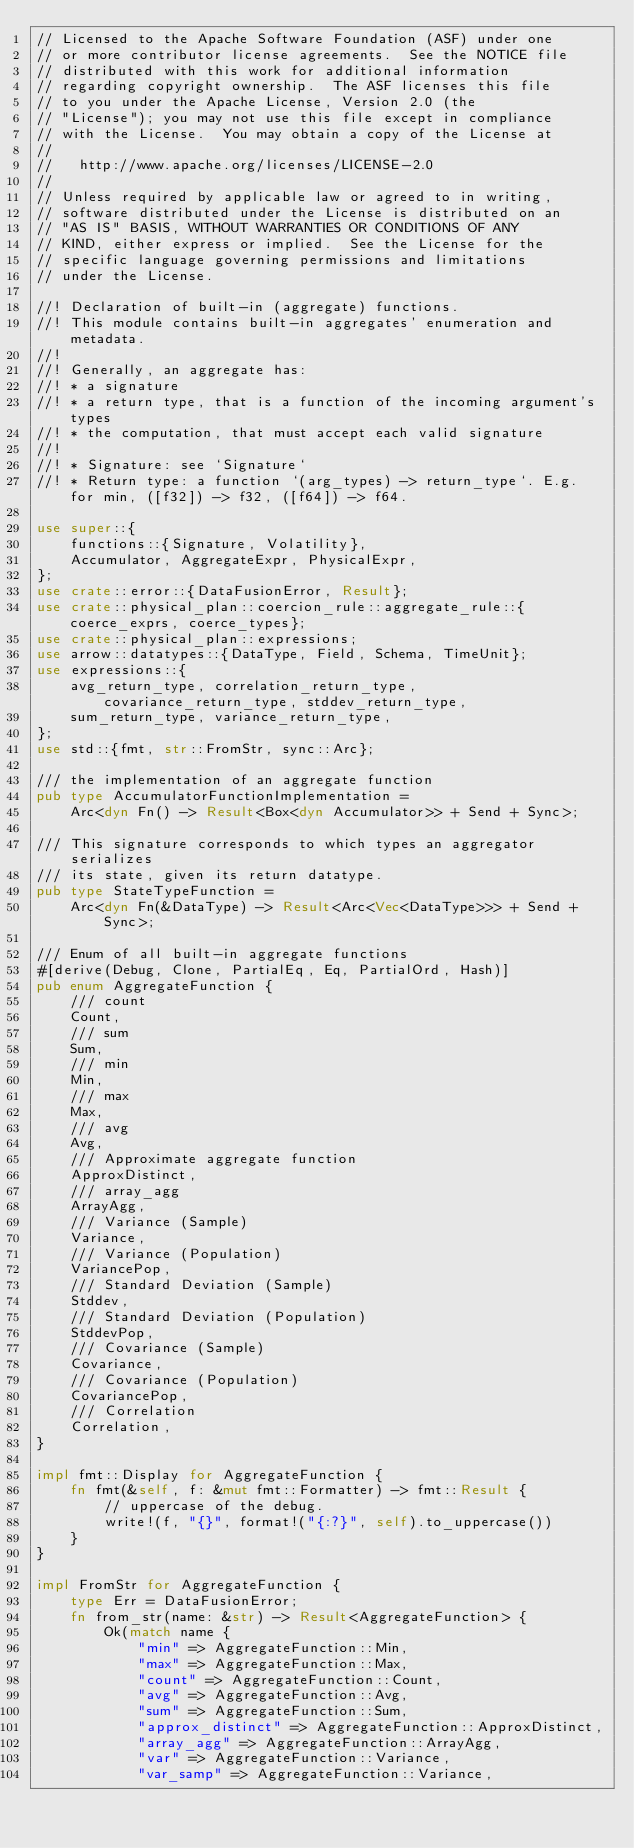Convert code to text. <code><loc_0><loc_0><loc_500><loc_500><_Rust_>// Licensed to the Apache Software Foundation (ASF) under one
// or more contributor license agreements.  See the NOTICE file
// distributed with this work for additional information
// regarding copyright ownership.  The ASF licenses this file
// to you under the Apache License, Version 2.0 (the
// "License"); you may not use this file except in compliance
// with the License.  You may obtain a copy of the License at
//
//   http://www.apache.org/licenses/LICENSE-2.0
//
// Unless required by applicable law or agreed to in writing,
// software distributed under the License is distributed on an
// "AS IS" BASIS, WITHOUT WARRANTIES OR CONDITIONS OF ANY
// KIND, either express or implied.  See the License for the
// specific language governing permissions and limitations
// under the License.

//! Declaration of built-in (aggregate) functions.
//! This module contains built-in aggregates' enumeration and metadata.
//!
//! Generally, an aggregate has:
//! * a signature
//! * a return type, that is a function of the incoming argument's types
//! * the computation, that must accept each valid signature
//!
//! * Signature: see `Signature`
//! * Return type: a function `(arg_types) -> return_type`. E.g. for min, ([f32]) -> f32, ([f64]) -> f64.

use super::{
    functions::{Signature, Volatility},
    Accumulator, AggregateExpr, PhysicalExpr,
};
use crate::error::{DataFusionError, Result};
use crate::physical_plan::coercion_rule::aggregate_rule::{coerce_exprs, coerce_types};
use crate::physical_plan::expressions;
use arrow::datatypes::{DataType, Field, Schema, TimeUnit};
use expressions::{
    avg_return_type, correlation_return_type, covariance_return_type, stddev_return_type,
    sum_return_type, variance_return_type,
};
use std::{fmt, str::FromStr, sync::Arc};

/// the implementation of an aggregate function
pub type AccumulatorFunctionImplementation =
    Arc<dyn Fn() -> Result<Box<dyn Accumulator>> + Send + Sync>;

/// This signature corresponds to which types an aggregator serializes
/// its state, given its return datatype.
pub type StateTypeFunction =
    Arc<dyn Fn(&DataType) -> Result<Arc<Vec<DataType>>> + Send + Sync>;

/// Enum of all built-in aggregate functions
#[derive(Debug, Clone, PartialEq, Eq, PartialOrd, Hash)]
pub enum AggregateFunction {
    /// count
    Count,
    /// sum
    Sum,
    /// min
    Min,
    /// max
    Max,
    /// avg
    Avg,
    /// Approximate aggregate function
    ApproxDistinct,
    /// array_agg
    ArrayAgg,
    /// Variance (Sample)
    Variance,
    /// Variance (Population)
    VariancePop,
    /// Standard Deviation (Sample)
    Stddev,
    /// Standard Deviation (Population)
    StddevPop,
    /// Covariance (Sample)
    Covariance,
    /// Covariance (Population)
    CovariancePop,
    /// Correlation
    Correlation,
}

impl fmt::Display for AggregateFunction {
    fn fmt(&self, f: &mut fmt::Formatter) -> fmt::Result {
        // uppercase of the debug.
        write!(f, "{}", format!("{:?}", self).to_uppercase())
    }
}

impl FromStr for AggregateFunction {
    type Err = DataFusionError;
    fn from_str(name: &str) -> Result<AggregateFunction> {
        Ok(match name {
            "min" => AggregateFunction::Min,
            "max" => AggregateFunction::Max,
            "count" => AggregateFunction::Count,
            "avg" => AggregateFunction::Avg,
            "sum" => AggregateFunction::Sum,
            "approx_distinct" => AggregateFunction::ApproxDistinct,
            "array_agg" => AggregateFunction::ArrayAgg,
            "var" => AggregateFunction::Variance,
            "var_samp" => AggregateFunction::Variance,</code> 